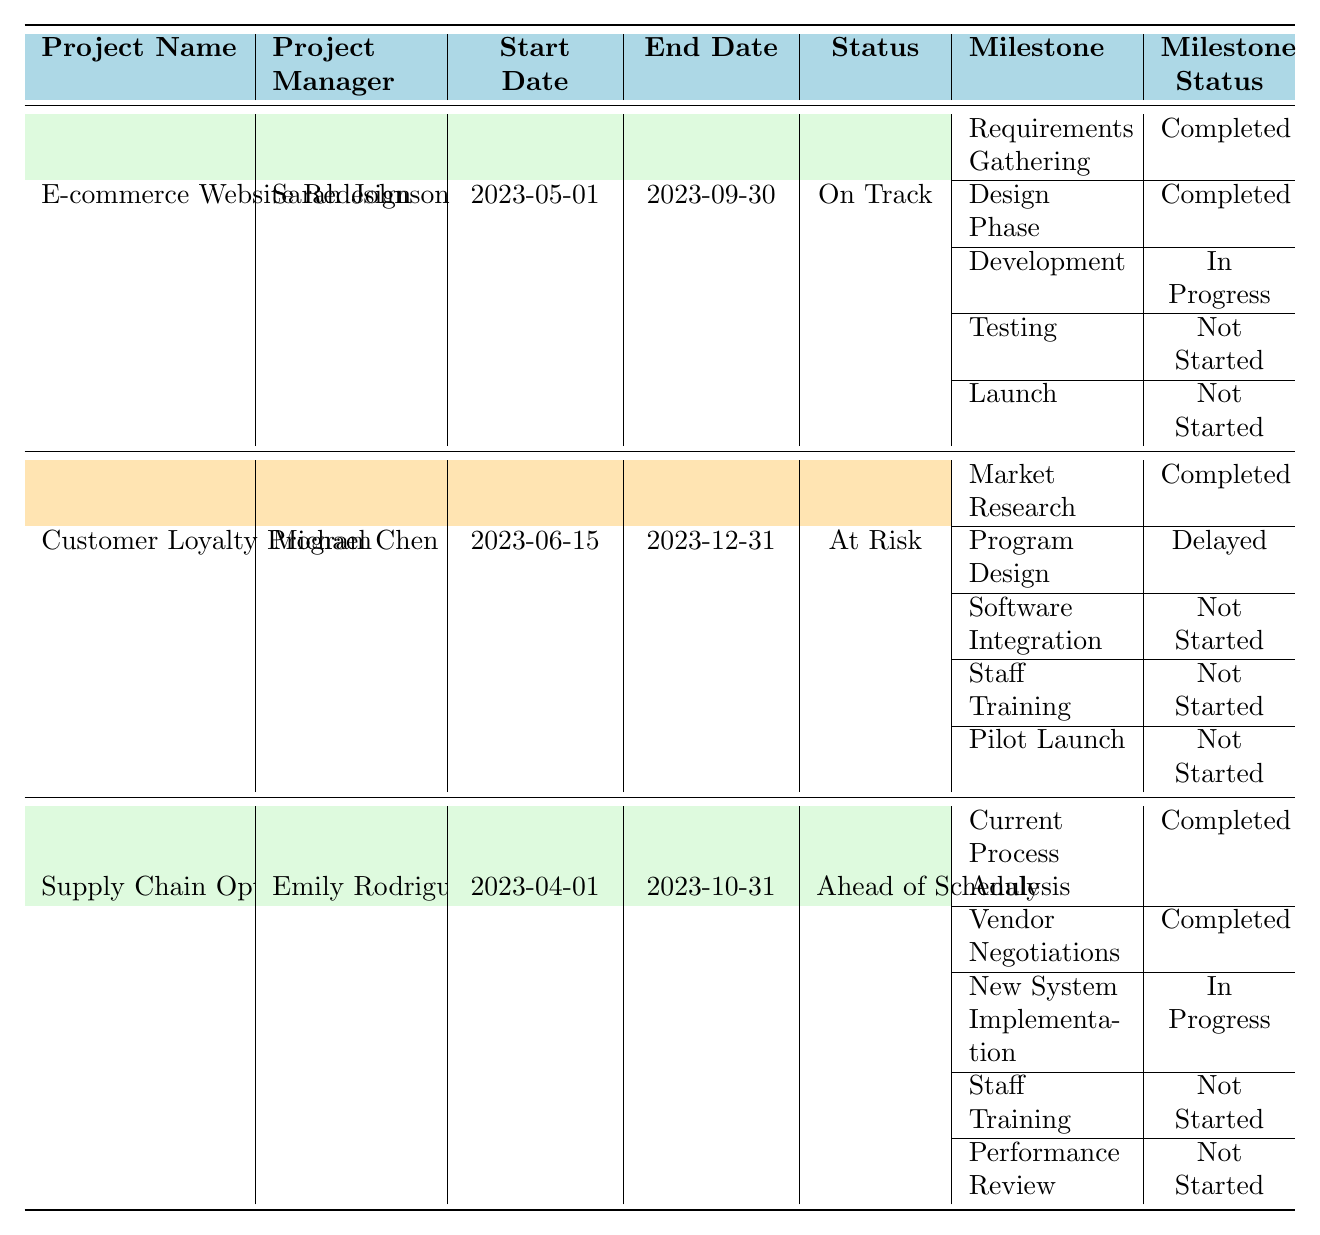What is the status of the "E-commerce Website Redesign" project? The status for the "E-commerce Website Redesign" project is listed as "On Track" in the table.
Answer: On Track Who is the project manager for the "Customer Loyalty Program"? The project manager for the "Customer Loyalty Program" is Michael Chen, as indicated in the table.
Answer: Michael Chen How many milestones are completed in the "Supply Chain Optimization" project? The "Supply Chain Optimization" project has two milestones that are marked as completed: "Current Process Analysis" and "Vendor Negotiations".
Answer: 2 What is the due date for the "Staff Training" milestone in the "Customer Loyalty Program"? The due date for the "Staff Training" milestone is listed as "2023-11-30" in the table.
Answer: 2023-11-30 Which project has the status "At Risk"? The "Customer Loyalty Program" has the status "At Risk", as shown in the table.
Answer: Customer Loyalty Program What is the difference in due dates between the "Launch" milestone in the "E-commerce Website Redesign" and the "Pilot Launch" in the "Customer Loyalty Program"? The "Launch" milestone is due on "2023-09-30" and the "Pilot Launch" is due on "2023-12-15". The difference is 15 days (October 1 to October 15).
Answer: 15 days Which project has the most delayed milestone and what is its name? The "Customer Loyalty Program" has the most delayed milestone called "Program Design," which is behind schedule according to the table.
Answer: Program Design Is there any project that is ahead of schedule? Yes, the "Supply Chain Optimization" project is noted as "Ahead of Schedule" in the table.
Answer: Yes How many milestones are not started in the "E-commerce Website Redesign"? The "E-commerce Website Redesign" has two milestones that are not started: "Testing" and "Launch".
Answer: 2 Which project has the latest ending date among the three listed projects? The "Customer Loyalty Program" ends on "2023-12-31", which is later than the other two projects that end earlier.
Answer: Customer Loyalty Program What are the statuses of the milestones in the "Supply Chain Optimization"? The statuses of the milestones in "Supply Chain Optimization" are: Current Process Analysis (Completed), Vendor Negotiations (Completed), New System Implementation (In Progress), Staff Training (Not Started), Performance Review (Not Started).
Answer: Completed, Completed, In Progress, Not Started, Not Started How many milestones are in the "E-commerce Website Redesign"? The "E-commerce Website Redesign" project has five milestones listed in the table.
Answer: 5 What is the status of the "Development" milestone in the "E-commerce Website Redesign"? The status of the "Development" milestone is "In Progress" according to the information in the table.
Answer: In Progress What is the project manager for the project with two completed milestones? The "Supply Chain Optimization" project, which has two completed milestones, is managed by Emily Rodriguez as listed in the table.
Answer: Emily Rodriguez 